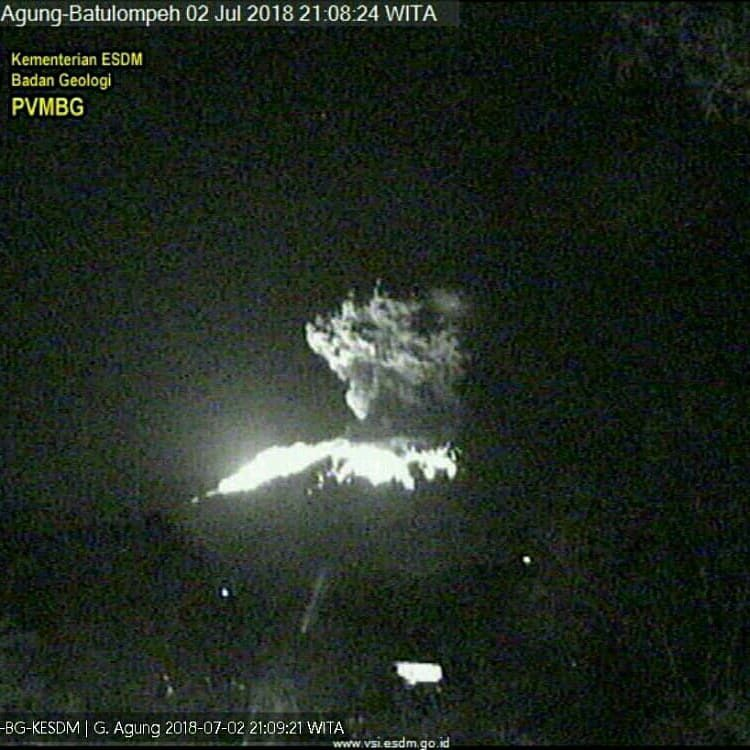Based on the visual information available in the image, what can be inferred about the potential impact of the volcanic eruption on nearby human settlements or infrastructure? From the image provided, we can observe an active volcanic eruption. The absence of evident human settlements or infrastructure within the frame suggests that the eruption could be occurring in a relatively remote or unpopulated area. This lack of visible structures might indicate that the immediate threat to human settlements and infrastructure is minimal from this perspective. However, the visibility of a government agency watermark highlights that the volcano is being actively monitored, suggesting awareness and possible preparation for any potential risks. While concrete conclusions about the impact cannot be made without additional context, including a broader view of the surroundings, the presence of monitoring indicates that the authorities are attentive to the potential dangers posed by the eruption. 